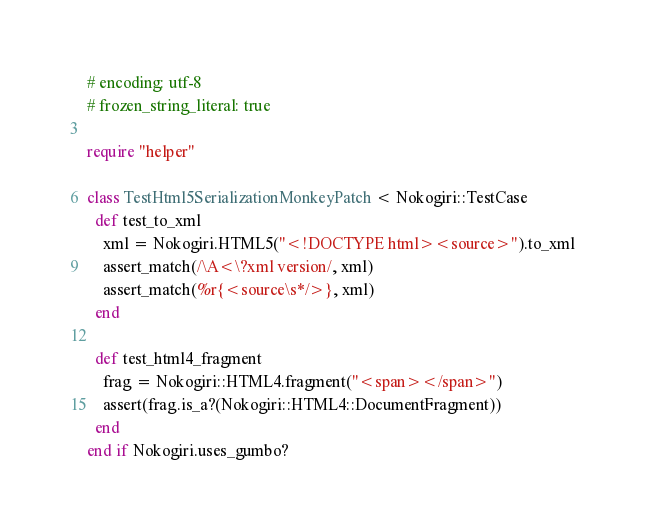Convert code to text. <code><loc_0><loc_0><loc_500><loc_500><_Ruby_># encoding: utf-8
# frozen_string_literal: true

require "helper"

class TestHtml5SerializationMonkeyPatch < Nokogiri::TestCase
  def test_to_xml
    xml = Nokogiri.HTML5("<!DOCTYPE html><source>").to_xml
    assert_match(/\A<\?xml version/, xml)
    assert_match(%r{<source\s*/>}, xml)
  end

  def test_html4_fragment
    frag = Nokogiri::HTML4.fragment("<span></span>")
    assert(frag.is_a?(Nokogiri::HTML4::DocumentFragment))
  end
end if Nokogiri.uses_gumbo?
</code> 